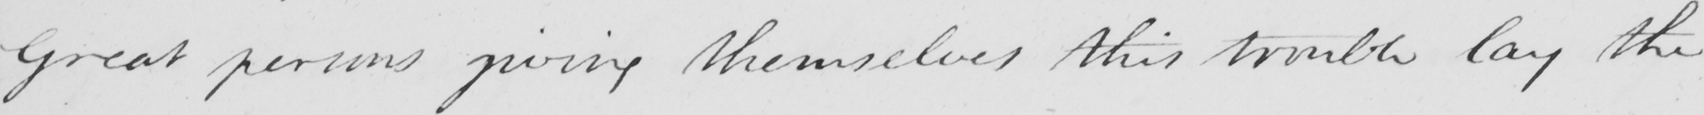Can you read and transcribe this handwriting? Great persons giving themselves this trouble lay the 